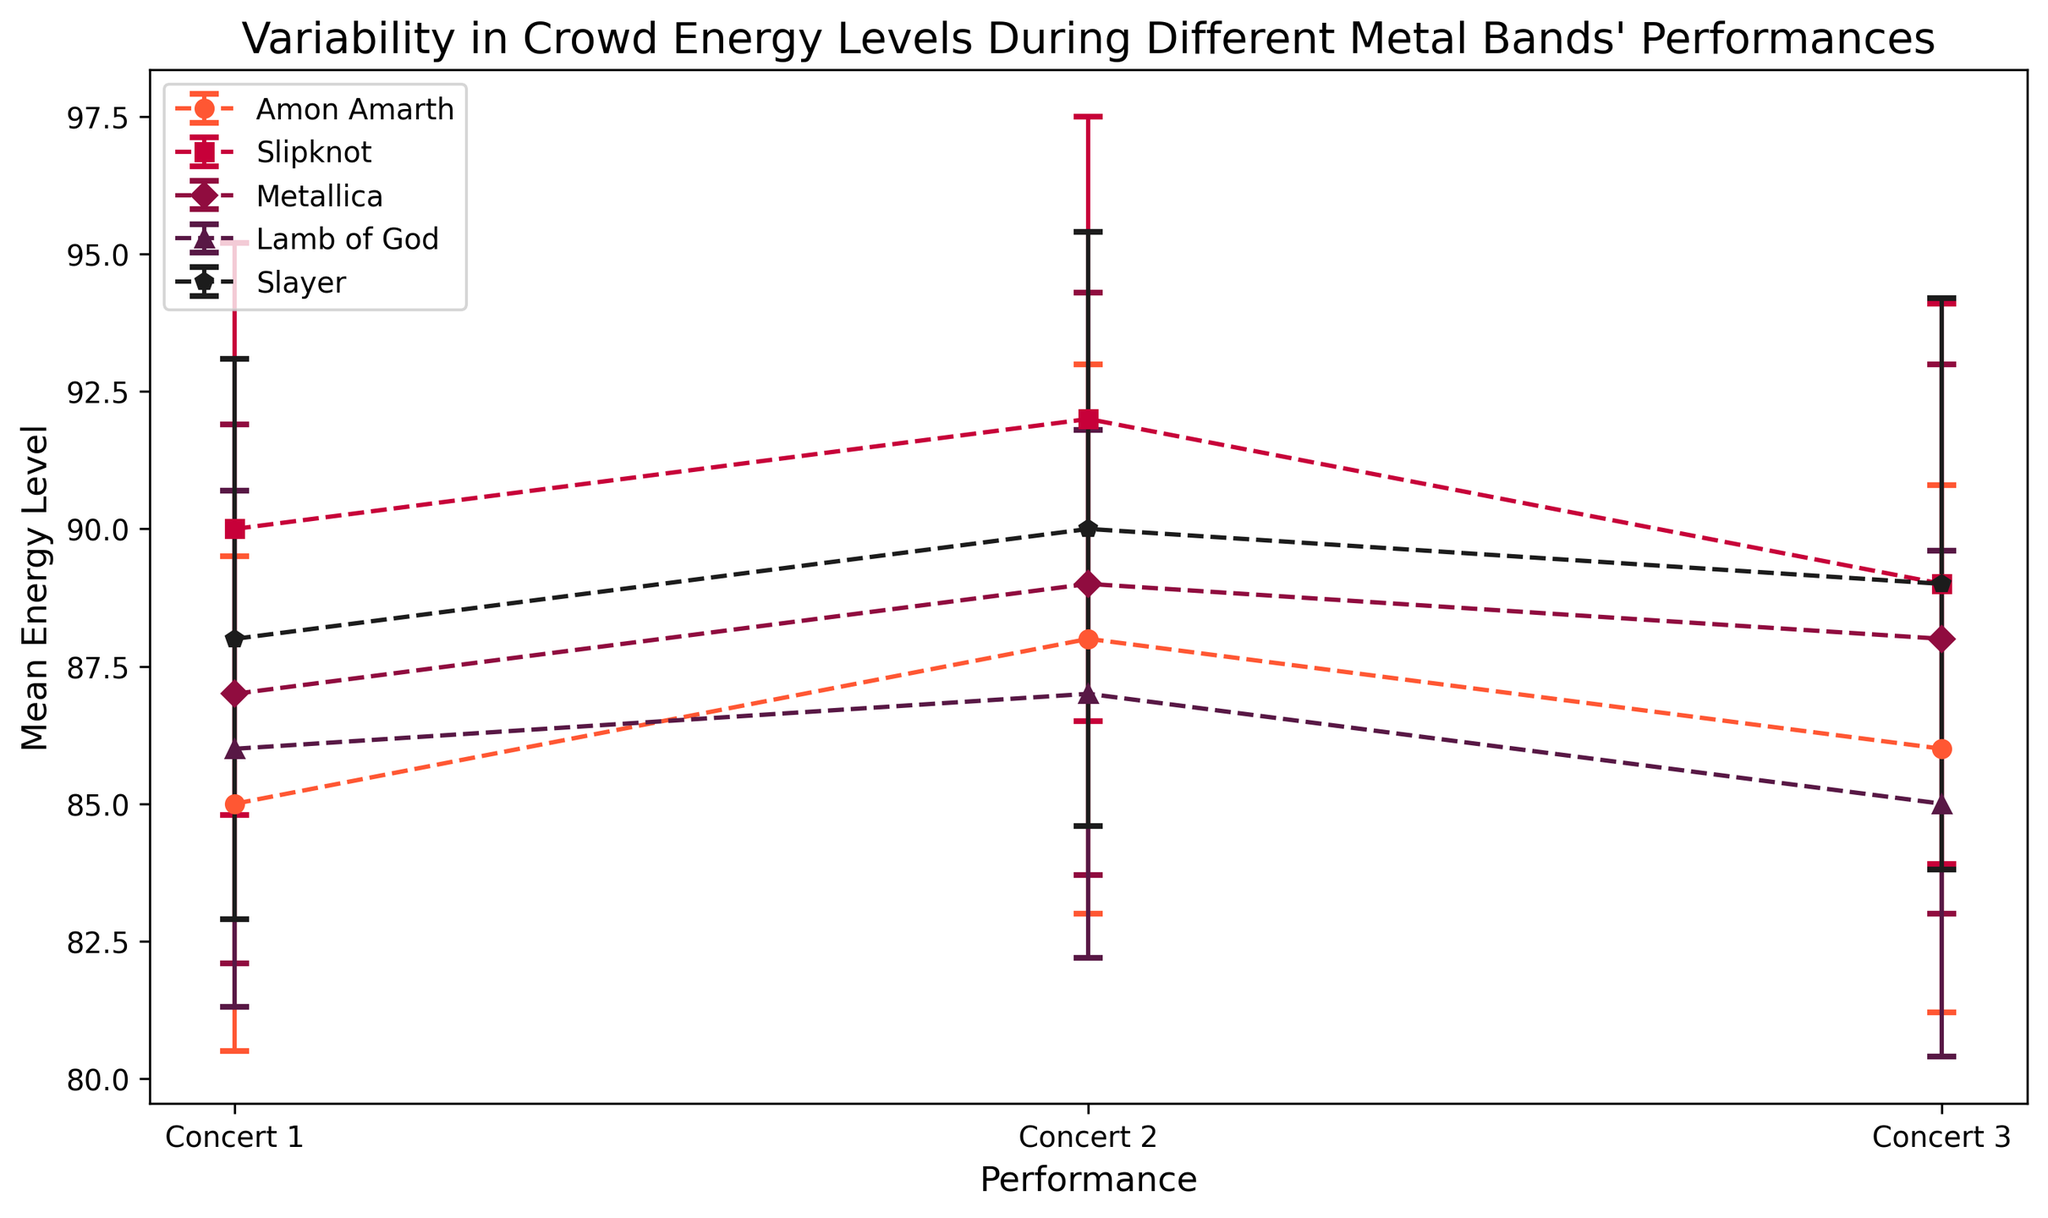Which band has the highest average energy level across all performances? Calculate the average energy level for each band by summing their performances' energy levels and dividing by the number of performances. Compare these averages to determine the highest.
Answer: Slipknot What's the difference in mean energy level between the highest and lowest energy performances of Metallica? Identify the mean energy levels of Metallica's three performances: 87, 89, and 88. Find the maximum (89) and minimum (87) values, then subtract the minimum from the maximum.
Answer: 2 Which band's performances display the widest range of energy levels based on the error bars? Compare the lengths of the error bars (standard deviations) for each band's performances and determine which has the widest range overall.
Answer: Slipknot How does the mean energy level of Lamb of God's performances compare to Amon Amarth's? Calculate the average energy level for Lamb of God (86, 87, 85) and Amon Amarth (85, 88, 86), then compare these averages.
Answer: Amon Amarth has a slightly higher average Which band's concerts show the most consistent crowd energy based on the error bars? Determine consistency by looking for the smallest average error bars (standard deviations) across the band's performances.
Answer: Lamb of God Which performance had the highest mean energy level among all bands? Identify the highest mean energy level value among all performances listed on the chart.
Answer: Slipknot Concert 2 